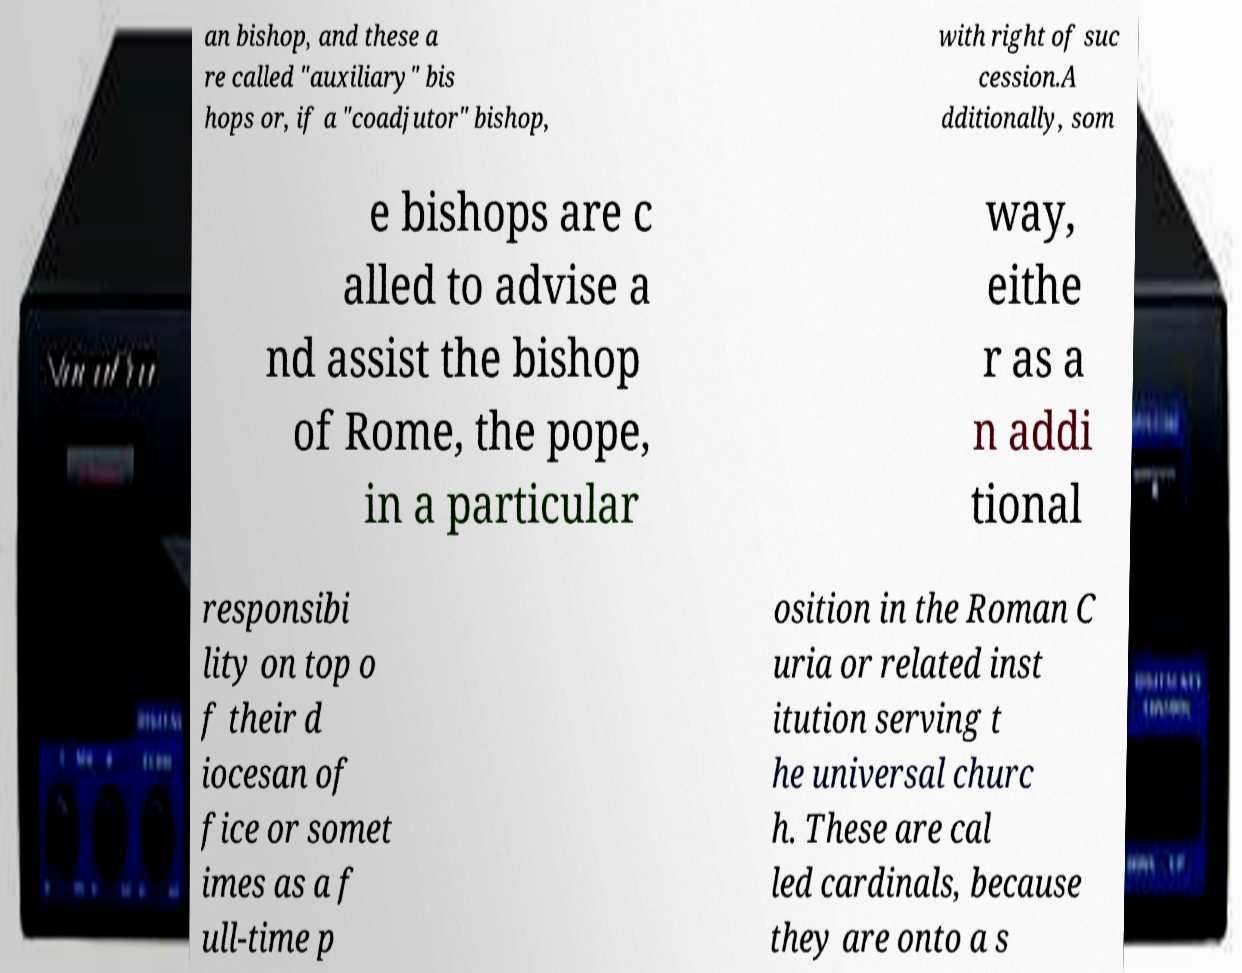Please read and relay the text visible in this image. What does it say? an bishop, and these a re called "auxiliary" bis hops or, if a "coadjutor" bishop, with right of suc cession.A dditionally, som e bishops are c alled to advise a nd assist the bishop of Rome, the pope, in a particular way, eithe r as a n addi tional responsibi lity on top o f their d iocesan of fice or somet imes as a f ull-time p osition in the Roman C uria or related inst itution serving t he universal churc h. These are cal led cardinals, because they are onto a s 